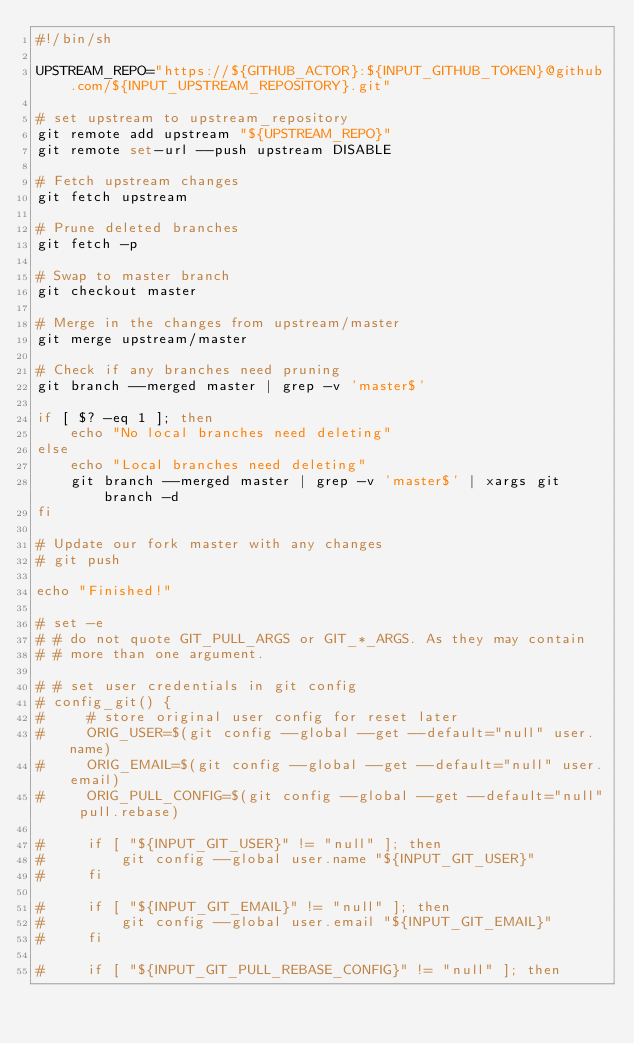Convert code to text. <code><loc_0><loc_0><loc_500><loc_500><_Bash_>#!/bin/sh

UPSTREAM_REPO="https://${GITHUB_ACTOR}:${INPUT_GITHUB_TOKEN}@github.com/${INPUT_UPSTREAM_REPOSITORY}.git"

# set upstream to upstream_repository
git remote add upstream "${UPSTREAM_REPO}"
git remote set-url --push upstream DISABLE

# Fetch upstream changes
git fetch upstream

# Prune deleted branches
git fetch -p

# Swap to master branch
git checkout master

# Merge in the changes from upstream/master
git merge upstream/master

# Check if any branches need pruning
git branch --merged master | grep -v 'master$'

if [ $? -eq 1 ]; then
    echo "No local branches need deleting"
else
    echo "Local branches need deleting"
    git branch --merged master | grep -v 'master$' | xargs git branch -d
fi

# Update our fork master with any changes
# git push

echo "Finished!"

# set -e
# # do not quote GIT_PULL_ARGS or GIT_*_ARGS. As they may contain
# # more than one argument.

# # set user credentials in git config
# config_git() {
#     # store original user config for reset later
#     ORIG_USER=$(git config --global --get --default="null" user.name)
#     ORIG_EMAIL=$(git config --global --get --default="null" user.email)
#     ORIG_PULL_CONFIG=$(git config --global --get --default="null" pull.rebase)

#     if [ "${INPUT_GIT_USER}" != "null" ]; then
#         git config --global user.name "${INPUT_GIT_USER}"
#     fi

#     if [ "${INPUT_GIT_EMAIL}" != "null" ]; then
#         git config --global user.email "${INPUT_GIT_EMAIL}"
#     fi

#     if [ "${INPUT_GIT_PULL_REBASE_CONFIG}" != "null" ]; then</code> 